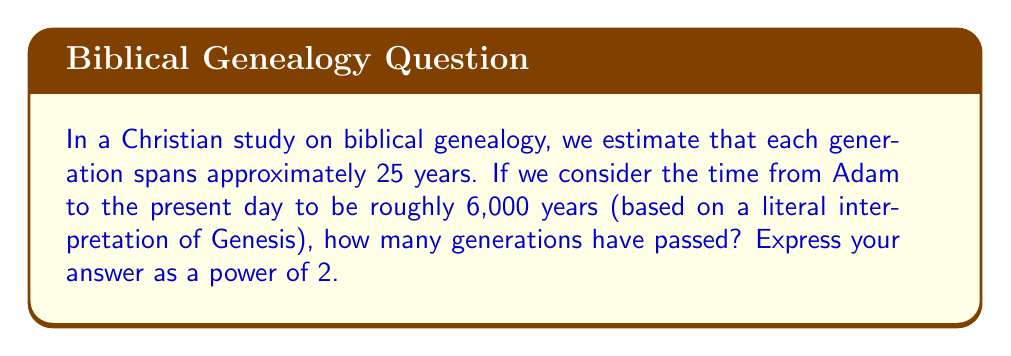Can you solve this math problem? Let's approach this step-by-step:

1) First, we need to calculate the number of generations:
   $\text{Number of generations} = \frac{\text{Total years}}{\text{Years per generation}}$
   
   $\text{Number of generations} = \frac{6000}{25} = 240$

2) Now, we need to express 240 as a power of 2. We can write this as:
   $240 = 2^x$

3) To solve for x, we can use logarithms:
   $\log_2(240) = x$

4) Using a calculator or logarithm tables:
   $\log_2(240) \approx 7.91$

5) Since we're asked for a power of 2, we need to round this to the nearest whole number:
   $7.91 \approx 8$

6) Therefore, $2^8 = 256$, which is the closest power of 2 to 240.

This means that approximately $2^8$ generations have passed since biblical times, according to this estimate.
Answer: $2^8$ generations 